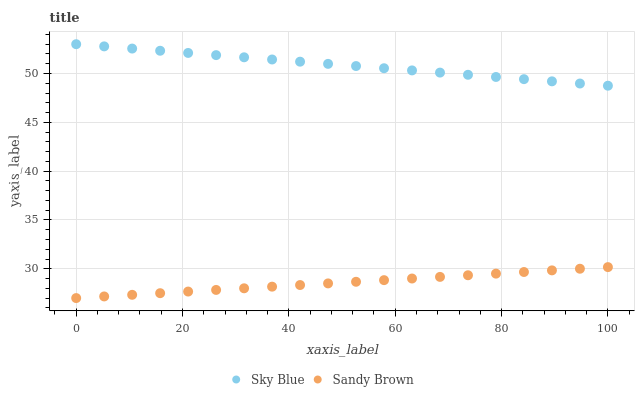Does Sandy Brown have the minimum area under the curve?
Answer yes or no. Yes. Does Sky Blue have the maximum area under the curve?
Answer yes or no. Yes. Does Sandy Brown have the maximum area under the curve?
Answer yes or no. No. Is Sandy Brown the smoothest?
Answer yes or no. Yes. Is Sky Blue the roughest?
Answer yes or no. Yes. Is Sandy Brown the roughest?
Answer yes or no. No. Does Sandy Brown have the lowest value?
Answer yes or no. Yes. Does Sky Blue have the highest value?
Answer yes or no. Yes. Does Sandy Brown have the highest value?
Answer yes or no. No. Is Sandy Brown less than Sky Blue?
Answer yes or no. Yes. Is Sky Blue greater than Sandy Brown?
Answer yes or no. Yes. Does Sandy Brown intersect Sky Blue?
Answer yes or no. No. 